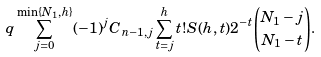Convert formula to latex. <formula><loc_0><loc_0><loc_500><loc_500>q \sum _ { j = 0 } ^ { \min \{ N _ { 1 } , h \} } ( - 1 ) ^ { j } { C } _ { n - 1 , j } \sum _ { t = j } ^ { h } t ! S ( h , t ) 2 ^ { - t } { \binom { N _ { 1 } - j } { N _ { 1 } - t } } .</formula> 